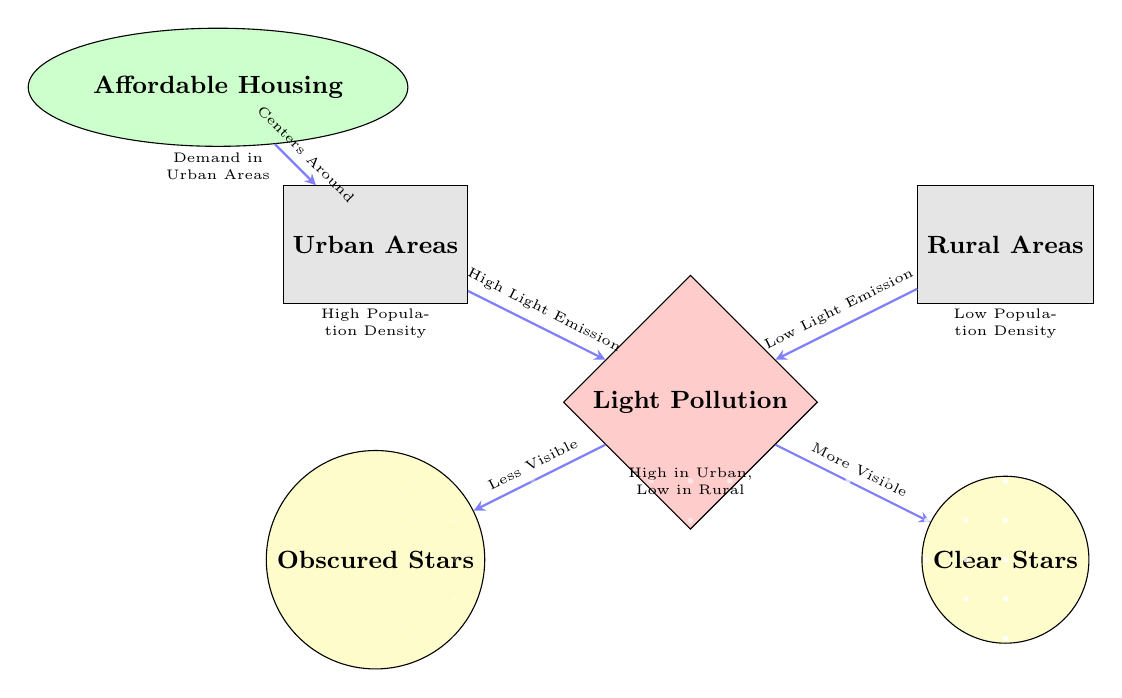What are the two types of areas shown in the diagram? The diagram explicitly identifies two types of areas using labeled nodes: 'Urban Areas' and 'Rural Areas'.
Answer: Urban Areas, Rural Areas How many star visibility outcomes are there in the diagram? There are two outcomes depicted for star visibility based on the area type, which are 'Obscured Stars' and 'Clear Stars'.
Answer: Two What does the diamond shape represent in the diagram? The diamond-shaped node labeled 'Light Pollution' indicates a key factor affecting star visibility according to the diagram.
Answer: Light Pollution What type of node is 'Affordable Housing' in the diagram? The 'Affordable Housing' node has an elliptical shape, distinguishing it from the other rectangular and circular nodes in the diagram.
Answer: Ellipse What is the relationship between urban areas and light pollution? The diagram indicates that urban areas create high light emission, which leads to increased light pollution.
Answer: High Light Emission Why do rural areas have clearer stars compared to urban areas according to the diagram? The diagram shows that rural areas experience low light emission, resulting in a lower level of light pollution and thus clearer visibility of stars.
Answer: Low Light Emission What connection does the diagram make between affordable housing and urban areas? The diagram indicates that affordable housing centers around urban areas, which are characterized by high population density.
Answer: Centers Around How is light pollution affecting star visibility differently in urban and rural areas? The diagram illustrates that light pollution causes stars to be 'Less Visible' in urban areas while they are 'More Visible' in rural areas.
Answer: Less Visible, More Visible What can be inferred about the demand for affordable housing from the diagram? The diagram suggests that there is a higher demand for affordable housing in urban areas, which are also impacted by high light pollution.
Answer: Demand in Urban Areas 